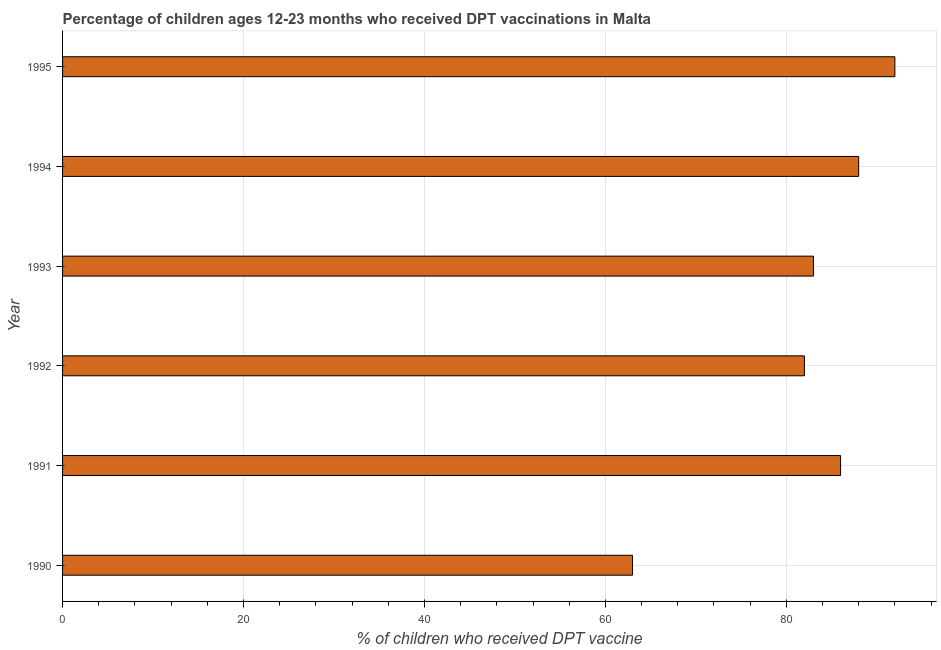Does the graph contain any zero values?
Ensure brevity in your answer.  No. Does the graph contain grids?
Ensure brevity in your answer.  Yes. What is the title of the graph?
Offer a terse response. Percentage of children ages 12-23 months who received DPT vaccinations in Malta. What is the label or title of the X-axis?
Provide a succinct answer. % of children who received DPT vaccine. What is the label or title of the Y-axis?
Offer a very short reply. Year. What is the percentage of children who received dpt vaccine in 1990?
Keep it short and to the point. 63. Across all years, what is the maximum percentage of children who received dpt vaccine?
Offer a very short reply. 92. Across all years, what is the minimum percentage of children who received dpt vaccine?
Offer a very short reply. 63. What is the sum of the percentage of children who received dpt vaccine?
Your answer should be compact. 494. What is the median percentage of children who received dpt vaccine?
Keep it short and to the point. 84.5. What is the ratio of the percentage of children who received dpt vaccine in 1994 to that in 1995?
Offer a very short reply. 0.96. Is the sum of the percentage of children who received dpt vaccine in 1990 and 1993 greater than the maximum percentage of children who received dpt vaccine across all years?
Provide a short and direct response. Yes. What is the difference between the highest and the lowest percentage of children who received dpt vaccine?
Give a very brief answer. 29. In how many years, is the percentage of children who received dpt vaccine greater than the average percentage of children who received dpt vaccine taken over all years?
Your answer should be very brief. 4. How many bars are there?
Your answer should be compact. 6. What is the difference between two consecutive major ticks on the X-axis?
Offer a very short reply. 20. What is the % of children who received DPT vaccine of 1990?
Provide a succinct answer. 63. What is the % of children who received DPT vaccine in 1991?
Provide a short and direct response. 86. What is the % of children who received DPT vaccine of 1992?
Keep it short and to the point. 82. What is the % of children who received DPT vaccine in 1993?
Offer a very short reply. 83. What is the % of children who received DPT vaccine of 1995?
Ensure brevity in your answer.  92. What is the difference between the % of children who received DPT vaccine in 1990 and 1991?
Your response must be concise. -23. What is the difference between the % of children who received DPT vaccine in 1990 and 1992?
Give a very brief answer. -19. What is the difference between the % of children who received DPT vaccine in 1990 and 1993?
Make the answer very short. -20. What is the difference between the % of children who received DPT vaccine in 1990 and 1994?
Your response must be concise. -25. What is the difference between the % of children who received DPT vaccine in 1990 and 1995?
Provide a short and direct response. -29. What is the difference between the % of children who received DPT vaccine in 1991 and 1992?
Offer a very short reply. 4. What is the difference between the % of children who received DPT vaccine in 1991 and 1993?
Ensure brevity in your answer.  3. What is the difference between the % of children who received DPT vaccine in 1991 and 1995?
Offer a terse response. -6. What is the difference between the % of children who received DPT vaccine in 1992 and 1993?
Your answer should be compact. -1. What is the difference between the % of children who received DPT vaccine in 1992 and 1995?
Offer a terse response. -10. What is the difference between the % of children who received DPT vaccine in 1993 and 1994?
Ensure brevity in your answer.  -5. What is the difference between the % of children who received DPT vaccine in 1994 and 1995?
Offer a very short reply. -4. What is the ratio of the % of children who received DPT vaccine in 1990 to that in 1991?
Give a very brief answer. 0.73. What is the ratio of the % of children who received DPT vaccine in 1990 to that in 1992?
Ensure brevity in your answer.  0.77. What is the ratio of the % of children who received DPT vaccine in 1990 to that in 1993?
Provide a short and direct response. 0.76. What is the ratio of the % of children who received DPT vaccine in 1990 to that in 1994?
Make the answer very short. 0.72. What is the ratio of the % of children who received DPT vaccine in 1990 to that in 1995?
Make the answer very short. 0.69. What is the ratio of the % of children who received DPT vaccine in 1991 to that in 1992?
Offer a very short reply. 1.05. What is the ratio of the % of children who received DPT vaccine in 1991 to that in 1993?
Your answer should be very brief. 1.04. What is the ratio of the % of children who received DPT vaccine in 1991 to that in 1994?
Provide a short and direct response. 0.98. What is the ratio of the % of children who received DPT vaccine in 1991 to that in 1995?
Your answer should be compact. 0.94. What is the ratio of the % of children who received DPT vaccine in 1992 to that in 1994?
Keep it short and to the point. 0.93. What is the ratio of the % of children who received DPT vaccine in 1992 to that in 1995?
Give a very brief answer. 0.89. What is the ratio of the % of children who received DPT vaccine in 1993 to that in 1994?
Your answer should be very brief. 0.94. What is the ratio of the % of children who received DPT vaccine in 1993 to that in 1995?
Provide a short and direct response. 0.9. 